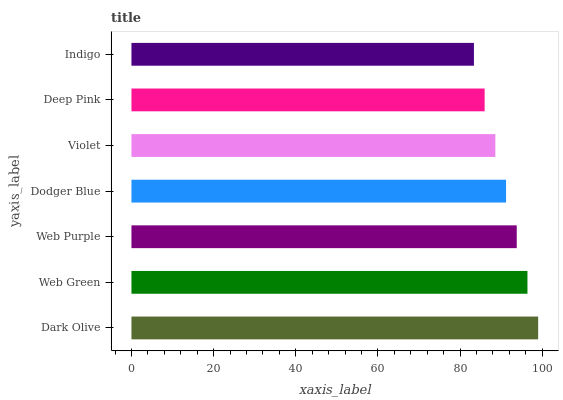Is Indigo the minimum?
Answer yes or no. Yes. Is Dark Olive the maximum?
Answer yes or no. Yes. Is Web Green the minimum?
Answer yes or no. No. Is Web Green the maximum?
Answer yes or no. No. Is Dark Olive greater than Web Green?
Answer yes or no. Yes. Is Web Green less than Dark Olive?
Answer yes or no. Yes. Is Web Green greater than Dark Olive?
Answer yes or no. No. Is Dark Olive less than Web Green?
Answer yes or no. No. Is Dodger Blue the high median?
Answer yes or no. Yes. Is Dodger Blue the low median?
Answer yes or no. Yes. Is Indigo the high median?
Answer yes or no. No. Is Deep Pink the low median?
Answer yes or no. No. 